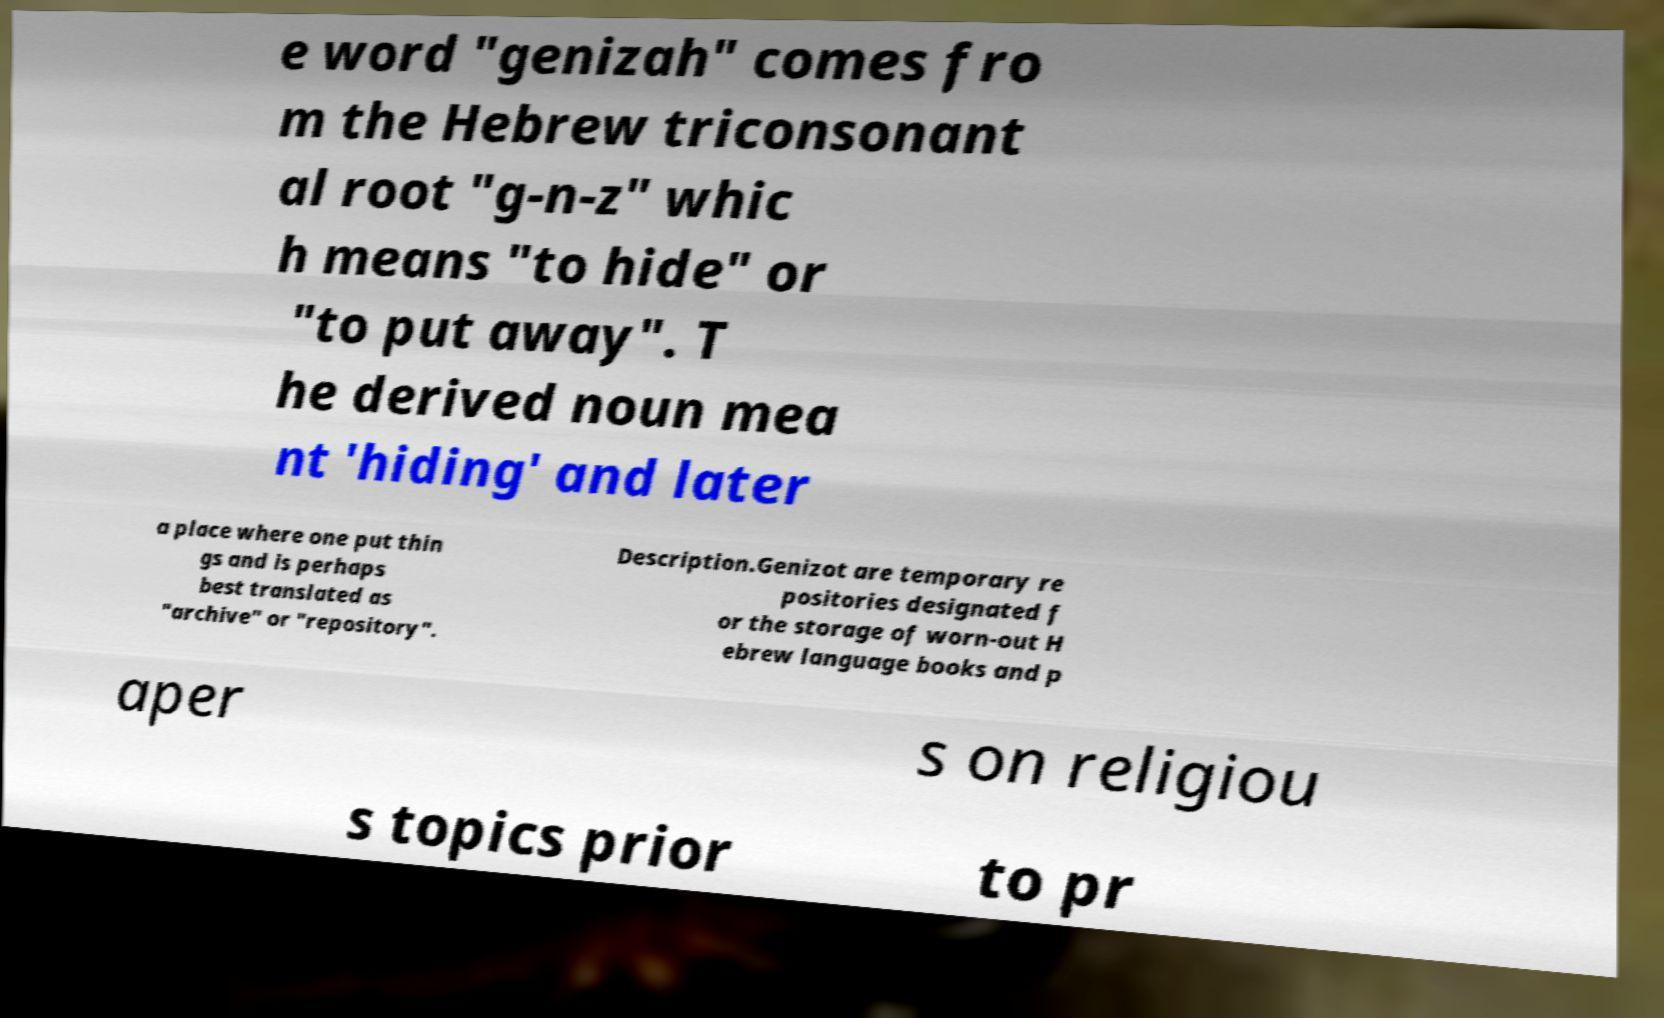Please read and relay the text visible in this image. What does it say? e word "genizah" comes fro m the Hebrew triconsonant al root "g-n-z" whic h means "to hide" or "to put away". T he derived noun mea nt 'hiding' and later a place where one put thin gs and is perhaps best translated as "archive" or "repository". Description.Genizot are temporary re positories designated f or the storage of worn-out H ebrew language books and p aper s on religiou s topics prior to pr 